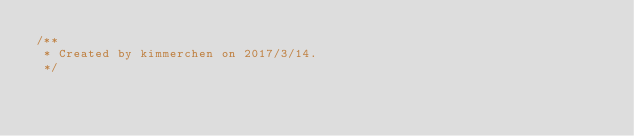<code> <loc_0><loc_0><loc_500><loc_500><_JavaScript_>/**
 * Created by kimmerchen on 2017/3/14.
 */
</code> 